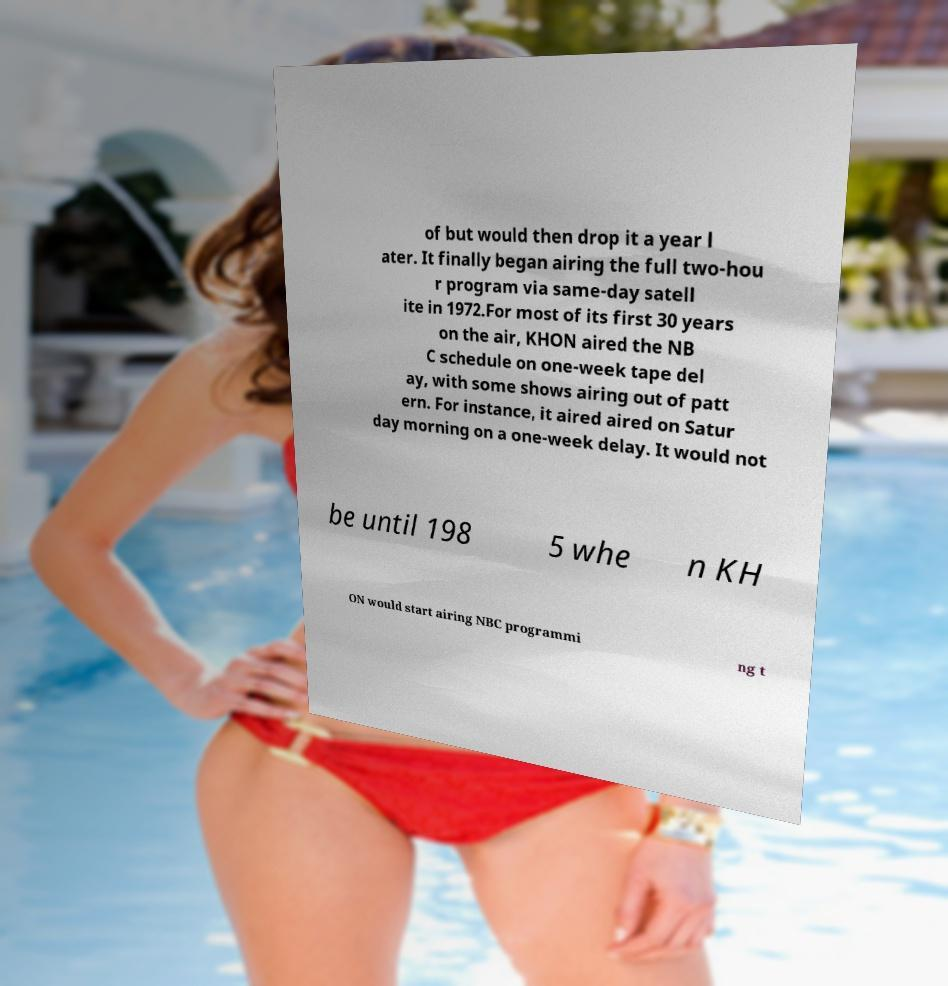What messages or text are displayed in this image? I need them in a readable, typed format. of but would then drop it a year l ater. It finally began airing the full two-hou r program via same-day satell ite in 1972.For most of its first 30 years on the air, KHON aired the NB C schedule on one-week tape del ay, with some shows airing out of patt ern. For instance, it aired aired on Satur day morning on a one-week delay. It would not be until 198 5 whe n KH ON would start airing NBC programmi ng t 